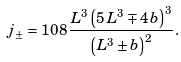<formula> <loc_0><loc_0><loc_500><loc_500>j _ { \pm } = 1 0 8 \, { \frac { { L } ^ { 3 } \left ( 5 \, { L } ^ { 3 } \mp 4 \, b \right ) ^ { 3 } } { \left ( { L } ^ { 3 } \pm b \right ) ^ { 2 } } } .</formula> 